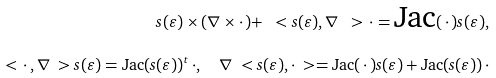Convert formula to latex. <formula><loc_0><loc_0><loc_500><loc_500>s ( \varepsilon ) \times ( \nabla \times \cdot \, ) + \ < s ( \varepsilon ) , \nabla \ > \, \cdot = \text {Jac} ( \, \cdot \, ) s ( \varepsilon ) , \\ \ < \, \cdot \, , \nabla \ > s ( \varepsilon ) = \text {Jac} ( s ( \varepsilon ) ) ^ { t } \, \cdot , \quad \nabla \ < s ( \varepsilon ) , \cdot \ > = \text {Jac} ( \, \cdot \, ) s ( \varepsilon ) + \text {Jac} ( s ( \varepsilon ) ) \, \cdot</formula> 